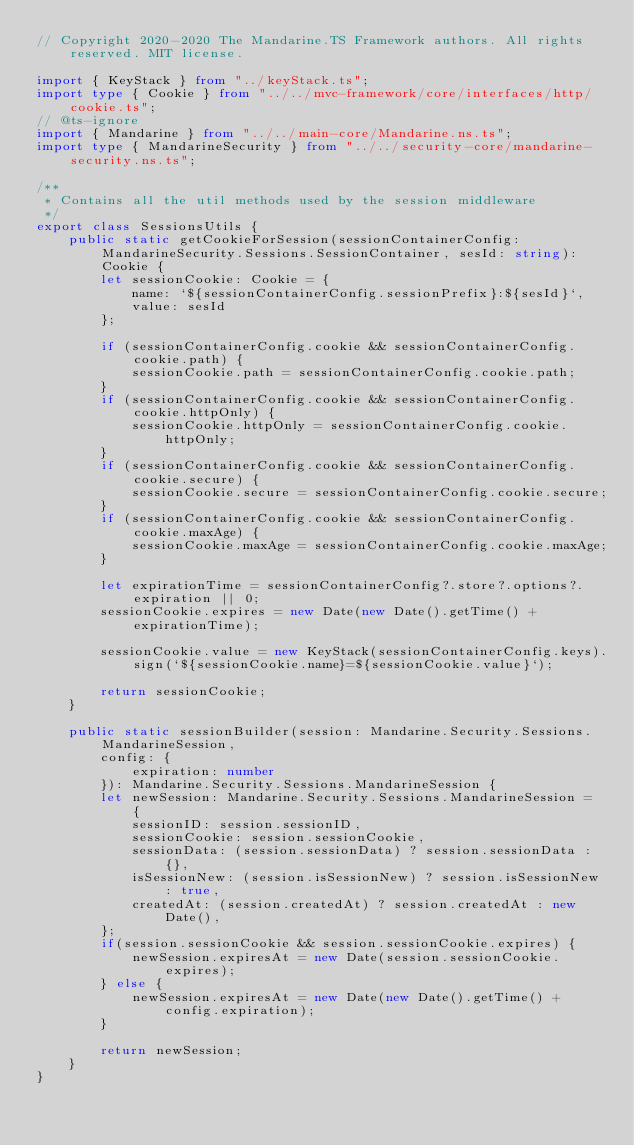Convert code to text. <code><loc_0><loc_0><loc_500><loc_500><_TypeScript_>// Copyright 2020-2020 The Mandarine.TS Framework authors. All rights reserved. MIT license.

import { KeyStack } from "../keyStack.ts";
import type { Cookie } from "../../mvc-framework/core/interfaces/http/cookie.ts";
// @ts-ignore
import { Mandarine } from "../../main-core/Mandarine.ns.ts";
import type { MandarineSecurity } from "../../security-core/mandarine-security.ns.ts";

/**
 * Contains all the util methods used by the session middleware
 */
export class SessionsUtils {
    public static getCookieForSession(sessionContainerConfig: MandarineSecurity.Sessions.SessionContainer, sesId: string): Cookie {
        let sessionCookie: Cookie = {
            name: `${sessionContainerConfig.sessionPrefix}:${sesId}`,
            value: sesId
        };

        if (sessionContainerConfig.cookie && sessionContainerConfig.cookie.path) {
            sessionCookie.path = sessionContainerConfig.cookie.path;
        }
        if (sessionContainerConfig.cookie && sessionContainerConfig.cookie.httpOnly) {
            sessionCookie.httpOnly = sessionContainerConfig.cookie.httpOnly;
        }
        if (sessionContainerConfig.cookie && sessionContainerConfig.cookie.secure) {
            sessionCookie.secure = sessionContainerConfig.cookie.secure;
        }
        if (sessionContainerConfig.cookie && sessionContainerConfig.cookie.maxAge) {
            sessionCookie.maxAge = sessionContainerConfig.cookie.maxAge;
        }

        let expirationTime = sessionContainerConfig?.store?.options?.expiration || 0;
        sessionCookie.expires = new Date(new Date().getTime() + expirationTime);

        sessionCookie.value = new KeyStack(sessionContainerConfig.keys).sign(`${sessionCookie.name}=${sessionCookie.value}`);

        return sessionCookie;
    }

    public static sessionBuilder(session: Mandarine.Security.Sessions.MandarineSession, 
        config: {
            expiration: number
        }): Mandarine.Security.Sessions.MandarineSession {
        let newSession: Mandarine.Security.Sessions.MandarineSession =  {
            sessionID: session.sessionID,
            sessionCookie: session.sessionCookie,
            sessionData: (session.sessionData) ? session.sessionData : {},
            isSessionNew: (session.isSessionNew) ? session.isSessionNew : true,
            createdAt: (session.createdAt) ? session.createdAt : new Date(),
        };
        if(session.sessionCookie && session.sessionCookie.expires) {
            newSession.expiresAt = new Date(session.sessionCookie.expires);
        } else {
            newSession.expiresAt = new Date(new Date().getTime() + config.expiration);
        }

        return newSession;
    }
}
</code> 